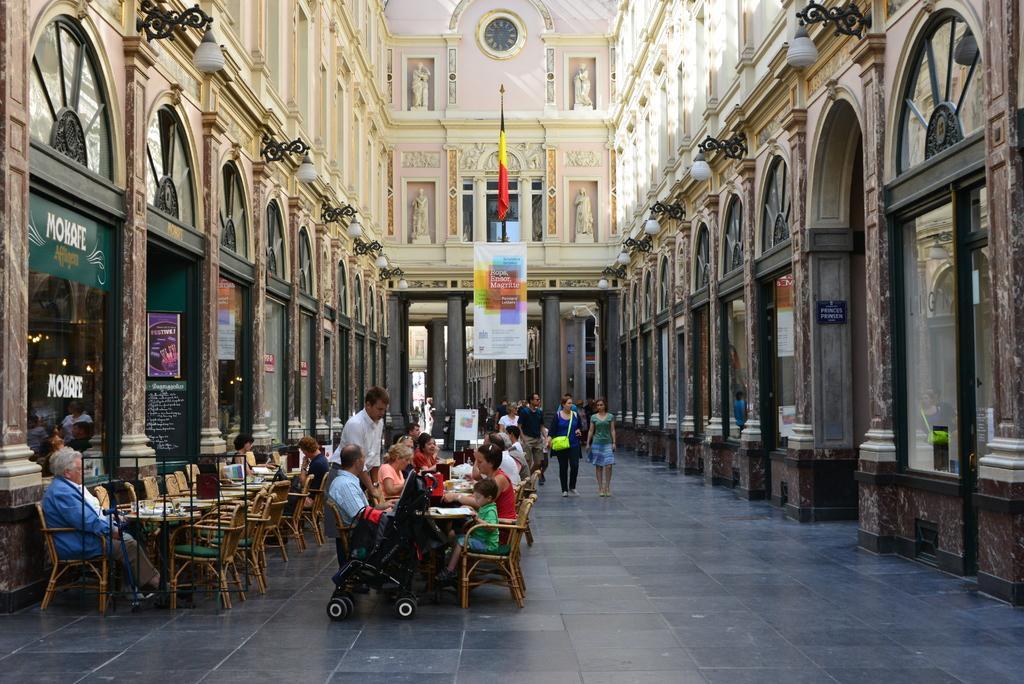In one or two sentences, can you explain what this image depicts? This is an inside view of a building. Here I can see few people are sitting on the chairs around the table and there are many empty chairs and also there is a baby chair. In the middle of the image there are few people walking on the floor and also there is a flag to a pole. Along with the flag a board is also attached to this pole. On the right and left side of the image there are many pillars. On the left side few posters are attached to the glass. At the top of the image there are few carvings on a wall. 